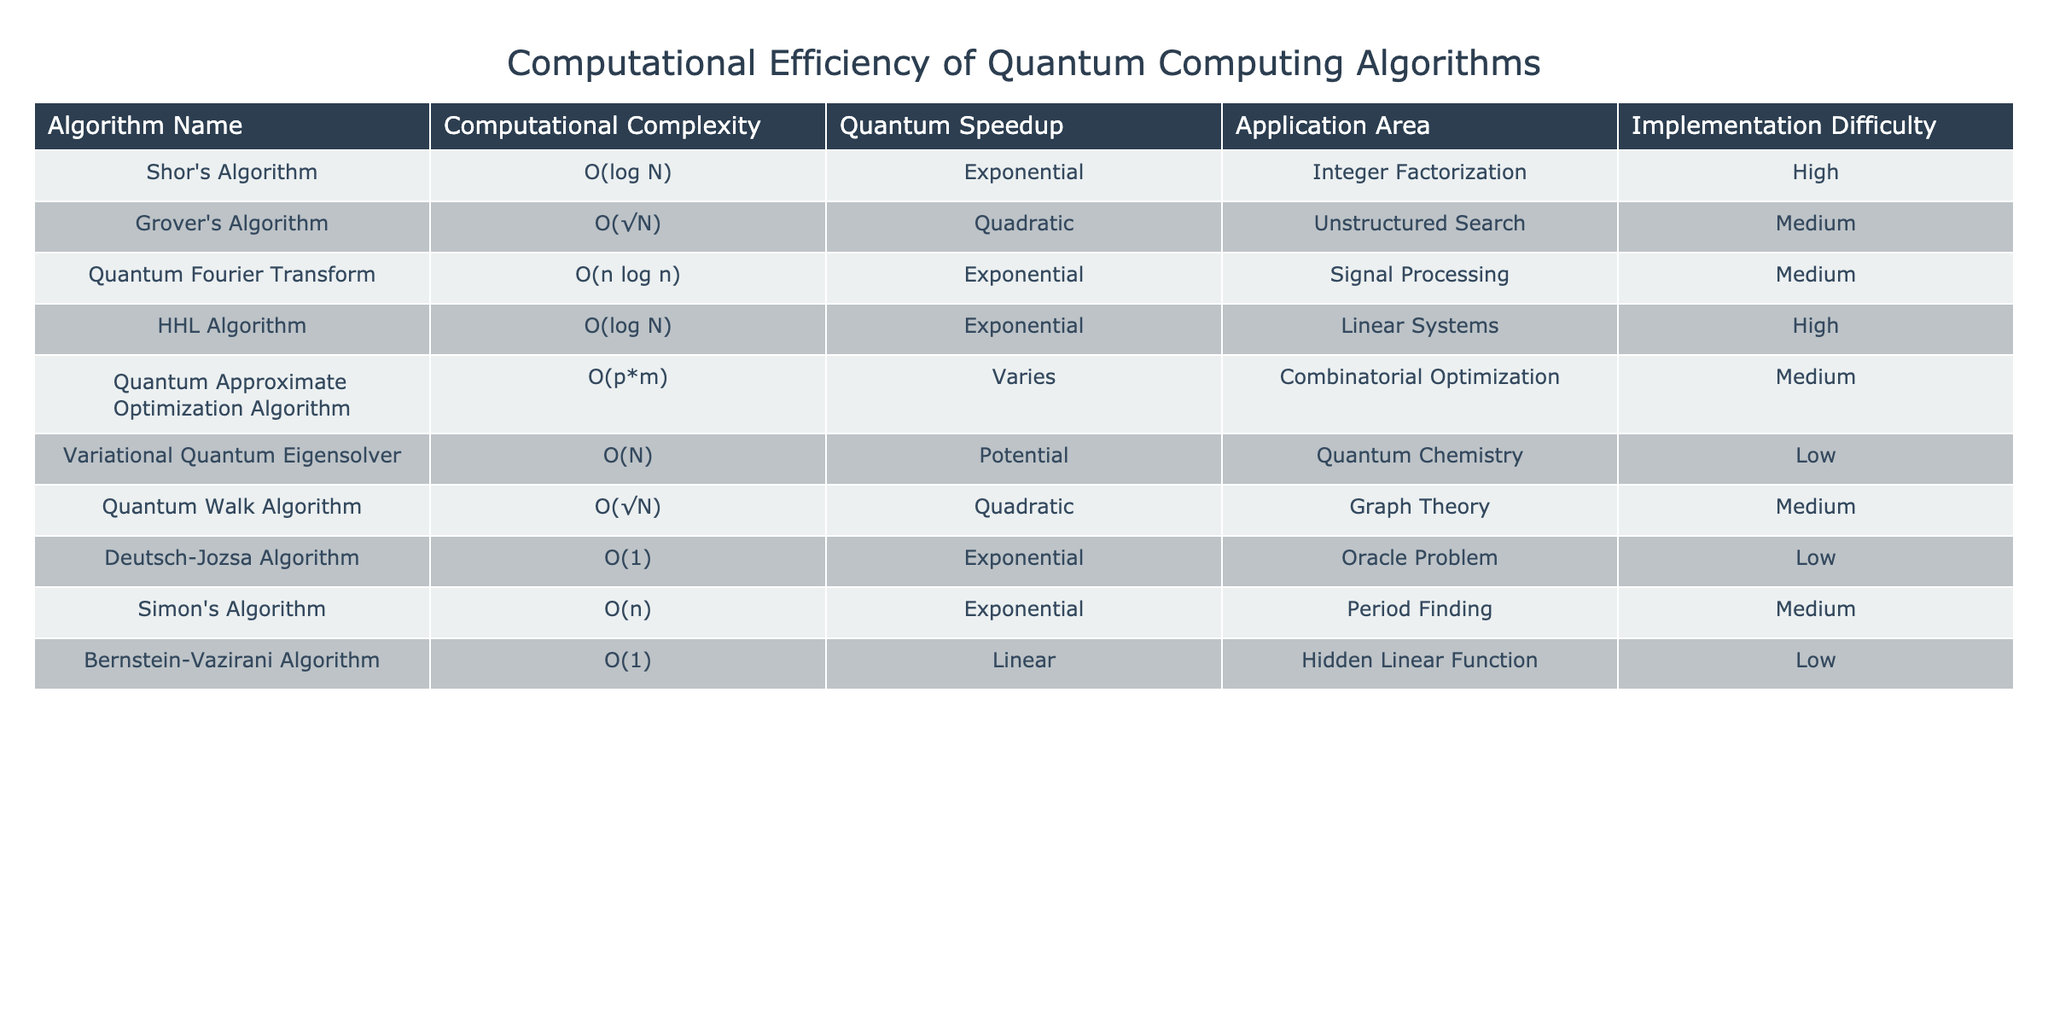What is the computational complexity of Grover's Algorithm? Grover's Algorithm has a computational complexity of O(√N), which can be found directly in the table under the "Computational Complexity" column.
Answer: O(√N) Which algorithm has the highest implementation difficulty? By examining the "Implementation Difficulty" column, we can see that both Shor's Algorithm and HHL Algorithm are listed as "High," making them the most difficult to implement.
Answer: Shor's Algorithm and HHL Algorithm Is the Quantum Speedup for the Variational Quantum Eigensolver exponential? The table shows that the Quantum Speedup for the Variational Quantum Eigensolver is listed as "Potential," not "Exponential," which means that this statement is false.
Answer: No What is the average computational complexity of the algorithms listed under "Polynomial" speedup? The table does not specifically mention a "Polynomial" speedup category; however, the only algorithm related is the Quantum Approximate Optimization Algorithm with an unspecified speedup based on p*m. Its complexity is O(p*m). Since there are no further values provided, we cannot calculate an average.
Answer: Cannot calculate average What is the relationship between application areas and implementation difficulties for algorithms that have exponential quantum speedups? The algorithms with exponential speedup include Shor's Algorithm, Quantum Fourier Transform, HHL Algorithm, Deutsch-Jozsa Algorithm, Simon's Algorithm. Their implementation difficulties vary: Shor's and HHL are high, Quantum Fourier Transform and Simon's are medium, and Deutsch-Jozsa is low. This indicates that high implementation difficulty does not always correlate with application area despite the quantum speedup.
Answer: Varies How many algorithms have a quadratic quantum speedup? From the table, Grover's Algorithm and Quantum Walk Algorithm both have a Quadratic quantum speedup. This can be counted by checking the "Quantum Speedup" column.
Answer: 2 Which application area has the lowest implementation difficulty? Upon reviewing the "Implementation Difficulty" column in the table, the "Quantum Chemistry" application area (Variational Quantum Eigensolver) is associated with a "Low" difficulty.
Answer: Quantum Chemistry 